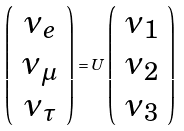<formula> <loc_0><loc_0><loc_500><loc_500>\left ( \begin{array} { c } \nu _ { e } \\ \nu _ { \mu } \\ \nu _ { \tau } \end{array} \right ) = U \left ( \begin{array} { c } \nu _ { 1 } \\ \nu _ { 2 } \\ \nu _ { 3 } \end{array} \right )</formula> 